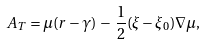Convert formula to latex. <formula><loc_0><loc_0><loc_500><loc_500>A _ { T } = \mu ( r - \gamma ) \, - \, \frac { 1 } { 2 } ( \xi - \xi _ { 0 } ) \nabla \mu ,</formula> 